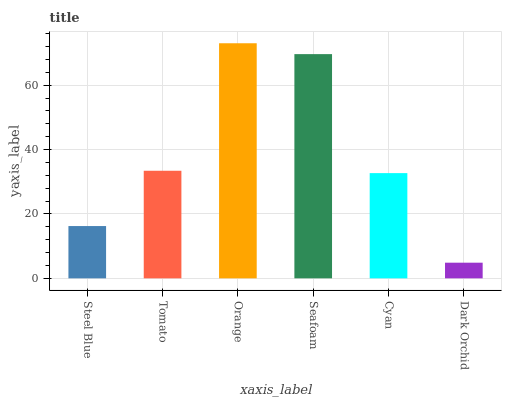Is Dark Orchid the minimum?
Answer yes or no. Yes. Is Orange the maximum?
Answer yes or no. Yes. Is Tomato the minimum?
Answer yes or no. No. Is Tomato the maximum?
Answer yes or no. No. Is Tomato greater than Steel Blue?
Answer yes or no. Yes. Is Steel Blue less than Tomato?
Answer yes or no. Yes. Is Steel Blue greater than Tomato?
Answer yes or no. No. Is Tomato less than Steel Blue?
Answer yes or no. No. Is Tomato the high median?
Answer yes or no. Yes. Is Cyan the low median?
Answer yes or no. Yes. Is Dark Orchid the high median?
Answer yes or no. No. Is Dark Orchid the low median?
Answer yes or no. No. 